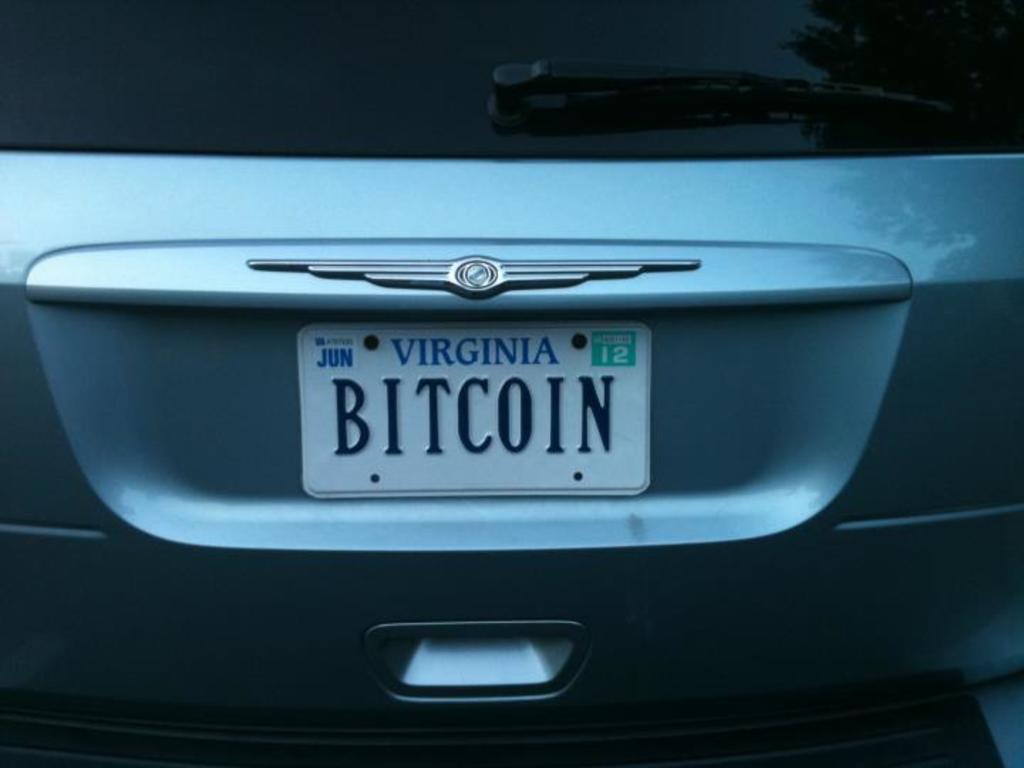Can you describe this image briefly? There is a zoom in picture of a car. We can see there is a number plate in the middle of this image. 